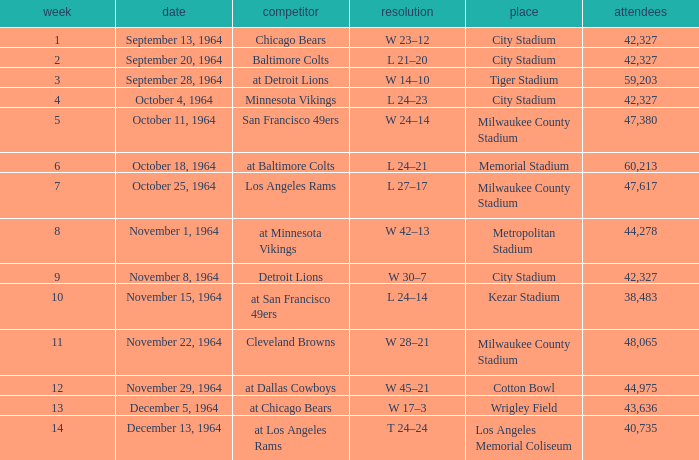What is the average week of the game on November 22, 1964 attended by 48,065? None. 